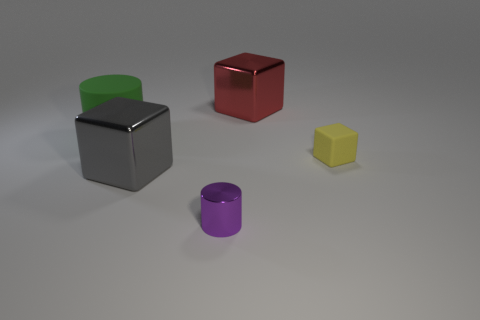What number of big red cubes are there?
Provide a succinct answer. 1. How many rubber objects are either red objects or small brown objects?
Provide a short and direct response. 0. How many metallic blocks are the same color as the tiny rubber cube?
Provide a succinct answer. 0. What material is the cylinder that is to the right of the matte thing that is left of the tiny metal object made of?
Keep it short and to the point. Metal. What is the size of the gray metal cube?
Ensure brevity in your answer.  Large. How many shiny cylinders have the same size as the red thing?
Provide a succinct answer. 0. How many red things have the same shape as the purple metallic object?
Offer a terse response. 0. Are there an equal number of large metallic cubes to the right of the yellow matte cube and gray objects?
Your response must be concise. No. What shape is the object that is the same size as the yellow cube?
Your answer should be compact. Cylinder. Is there a gray matte thing that has the same shape as the big red metallic thing?
Offer a very short reply. No. 